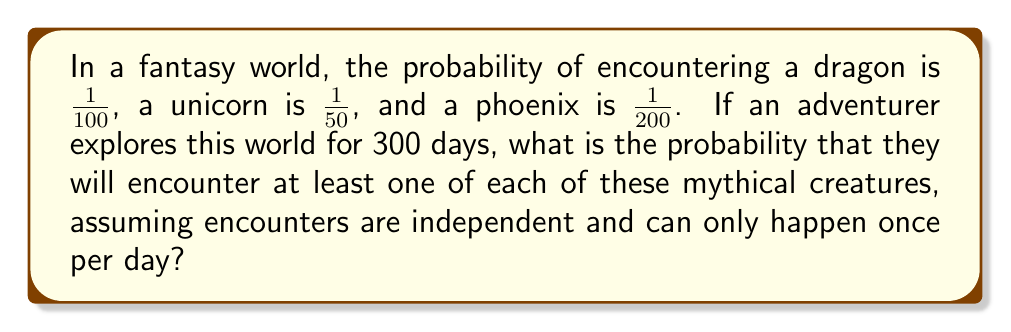Can you solve this math problem? Let's approach this step-by-step:

1) First, let's calculate the probability of encountering each creature at least once in 300 days:

   For dragons: $P(D) = 1 - (\frac{99}{100})^{300}$
   For unicorns: $P(U) = 1 - (\frac{49}{50})^{300}$
   For phoenixes: $P(P) = 1 - (\frac{199}{200})^{300}$

2) Calculate these probabilities:
   
   $P(D) \approx 0.9517$
   $P(U) \approx 0.9975$
   $P(P) \approx 0.7769$

3) The probability of encountering all three is the product of these individual probabilities:

   $P(\text{all three}) = P(D) \times P(U) \times P(P)$

4) Substituting the values:

   $P(\text{all three}) \approx 0.9517 \times 0.9975 \times 0.7769$

5) Calculating the final result:

   $P(\text{all three}) \approx 0.7372$

Thus, the probability of encountering at least one of each creature in 300 days is approximately 0.7372 or 73.72%.
Answer: $0.7372$ or $73.72\%$ 